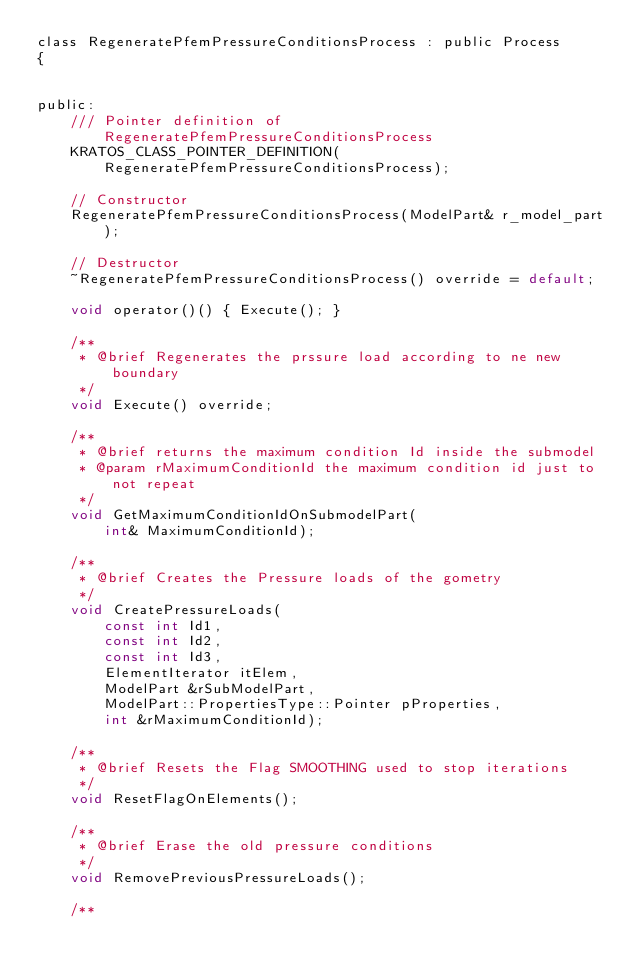<code> <loc_0><loc_0><loc_500><loc_500><_C_>class RegeneratePfemPressureConditionsProcess : public Process
{


public:
    /// Pointer definition of RegeneratePfemPressureConditionsProcess
    KRATOS_CLASS_POINTER_DEFINITION(RegeneratePfemPressureConditionsProcess);

    // Constructor
    RegeneratePfemPressureConditionsProcess(ModelPart& r_model_part);

    // Destructor
    ~RegeneratePfemPressureConditionsProcess() override = default;

    void operator()() { Execute(); }

    /**
     * @brief Regenerates the prssure load according to ne new boundary
     */
    void Execute() override;

    /**
     * @brief returns the maximum condition Id inside the submodel
     * @param rMaximumConditionId the maximum condition id just to not repeat
     */
    void GetMaximumConditionIdOnSubmodelPart(
        int& MaximumConditionId);

    /**
     * @brief Creates the Pressure loads of the gometry
     */
    void CreatePressureLoads(
        const int Id1,
        const int Id2,
        const int Id3,
        ElementIterator itElem,
        ModelPart &rSubModelPart,
        ModelPart::PropertiesType::Pointer pProperties,
        int &rMaximumConditionId);

    /**
     * @brief Resets the Flag SMOOTHING used to stop iterations
     */
    void ResetFlagOnElements();

    /**
     * @brief Erase the old pressure conditions
     */
    void RemovePreviousPressureLoads();

    /**</code> 